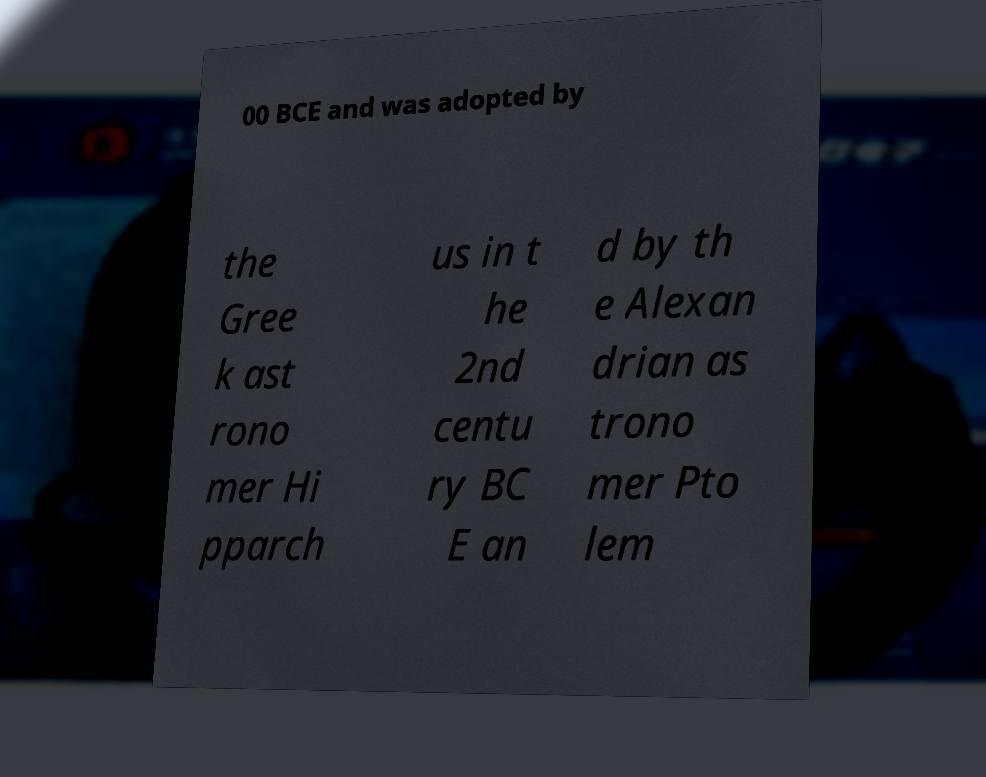Can you read and provide the text displayed in the image?This photo seems to have some interesting text. Can you extract and type it out for me? 00 BCE and was adopted by the Gree k ast rono mer Hi pparch us in t he 2nd centu ry BC E an d by th e Alexan drian as trono mer Pto lem 